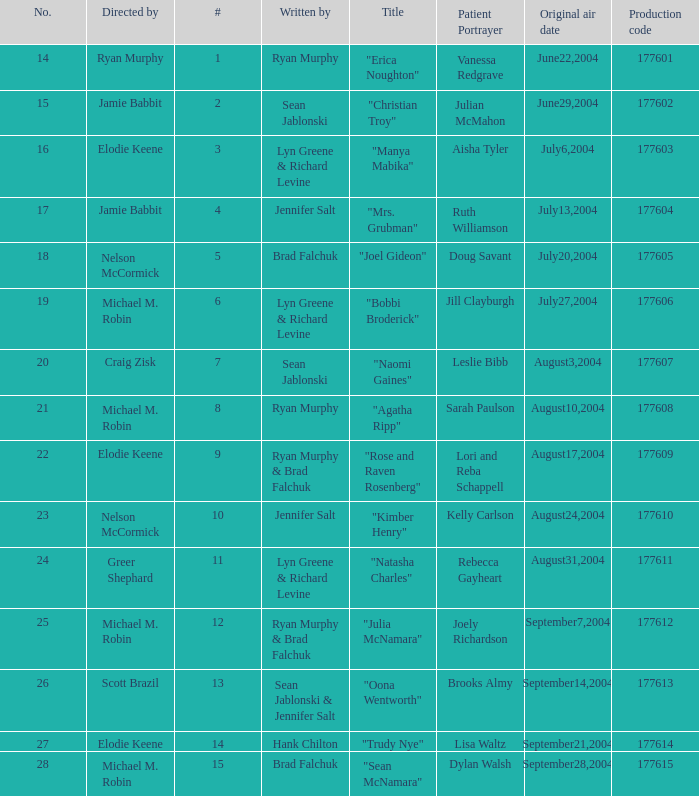What is the highest numbered episode with patient portrayer doug savant? 5.0. 